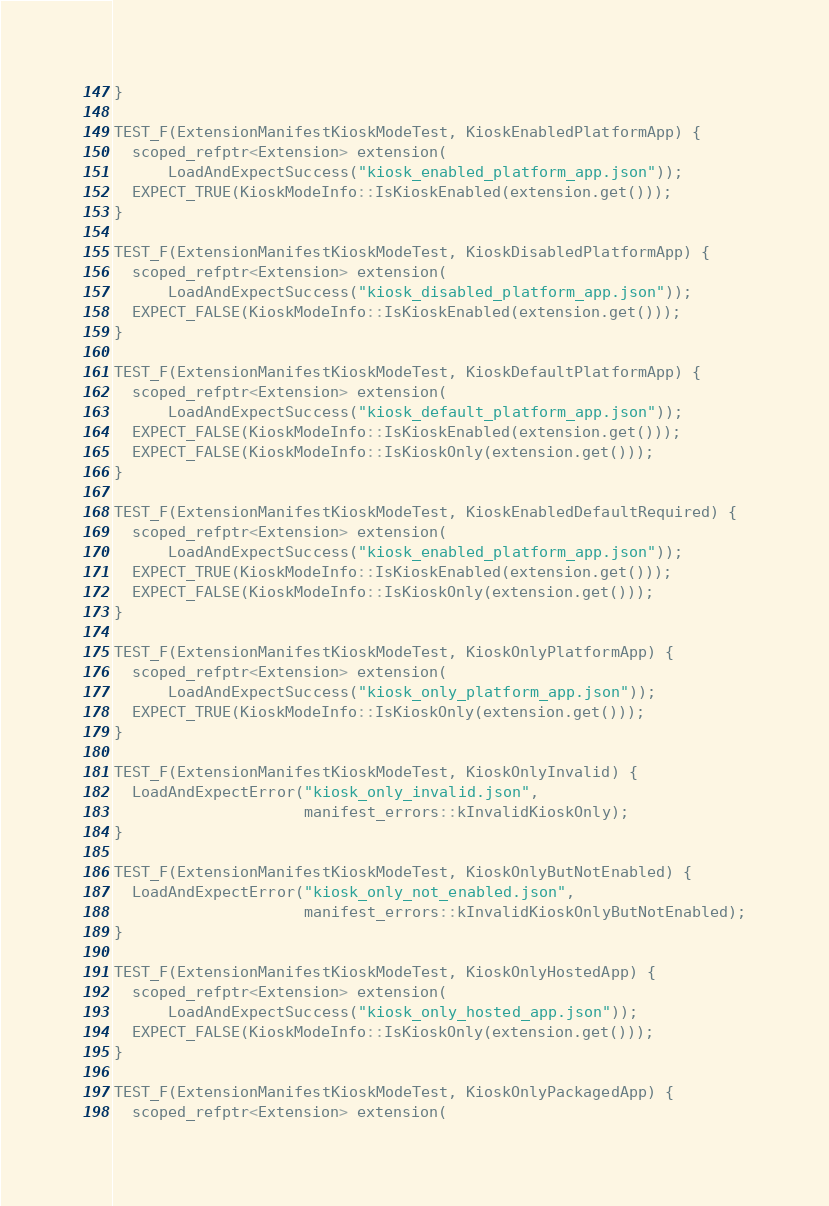Convert code to text. <code><loc_0><loc_0><loc_500><loc_500><_C++_>}

TEST_F(ExtensionManifestKioskModeTest, KioskEnabledPlatformApp) {
  scoped_refptr<Extension> extension(
      LoadAndExpectSuccess("kiosk_enabled_platform_app.json"));
  EXPECT_TRUE(KioskModeInfo::IsKioskEnabled(extension.get()));
}

TEST_F(ExtensionManifestKioskModeTest, KioskDisabledPlatformApp) {
  scoped_refptr<Extension> extension(
      LoadAndExpectSuccess("kiosk_disabled_platform_app.json"));
  EXPECT_FALSE(KioskModeInfo::IsKioskEnabled(extension.get()));
}

TEST_F(ExtensionManifestKioskModeTest, KioskDefaultPlatformApp) {
  scoped_refptr<Extension> extension(
      LoadAndExpectSuccess("kiosk_default_platform_app.json"));
  EXPECT_FALSE(KioskModeInfo::IsKioskEnabled(extension.get()));
  EXPECT_FALSE(KioskModeInfo::IsKioskOnly(extension.get()));
}

TEST_F(ExtensionManifestKioskModeTest, KioskEnabledDefaultRequired) {
  scoped_refptr<Extension> extension(
      LoadAndExpectSuccess("kiosk_enabled_platform_app.json"));
  EXPECT_TRUE(KioskModeInfo::IsKioskEnabled(extension.get()));
  EXPECT_FALSE(KioskModeInfo::IsKioskOnly(extension.get()));
}

TEST_F(ExtensionManifestKioskModeTest, KioskOnlyPlatformApp) {
  scoped_refptr<Extension> extension(
      LoadAndExpectSuccess("kiosk_only_platform_app.json"));
  EXPECT_TRUE(KioskModeInfo::IsKioskOnly(extension.get()));
}

TEST_F(ExtensionManifestKioskModeTest, KioskOnlyInvalid) {
  LoadAndExpectError("kiosk_only_invalid.json",
                     manifest_errors::kInvalidKioskOnly);
}

TEST_F(ExtensionManifestKioskModeTest, KioskOnlyButNotEnabled) {
  LoadAndExpectError("kiosk_only_not_enabled.json",
                     manifest_errors::kInvalidKioskOnlyButNotEnabled);
}

TEST_F(ExtensionManifestKioskModeTest, KioskOnlyHostedApp) {
  scoped_refptr<Extension> extension(
      LoadAndExpectSuccess("kiosk_only_hosted_app.json"));
  EXPECT_FALSE(KioskModeInfo::IsKioskOnly(extension.get()));
}

TEST_F(ExtensionManifestKioskModeTest, KioskOnlyPackagedApp) {
  scoped_refptr<Extension> extension(</code> 